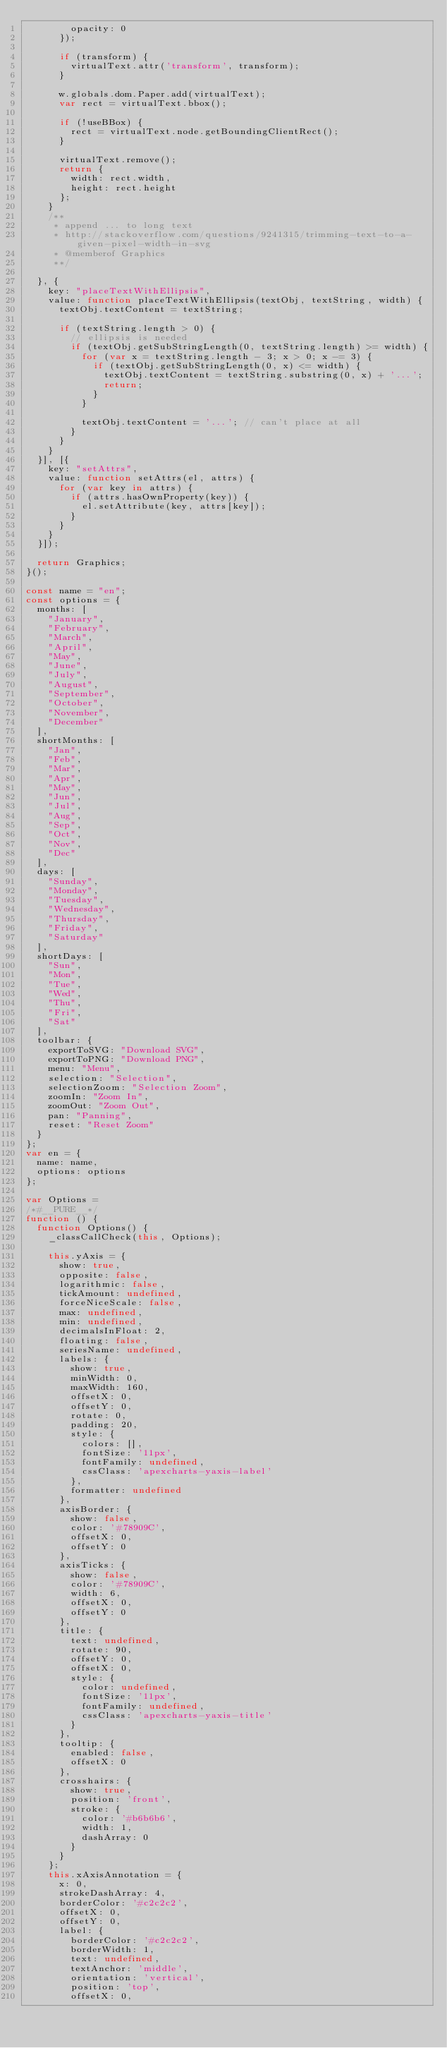Convert code to text. <code><loc_0><loc_0><loc_500><loc_500><_JavaScript_>        opacity: 0
      });

      if (transform) {
        virtualText.attr('transform', transform);
      }

      w.globals.dom.Paper.add(virtualText);
      var rect = virtualText.bbox();

      if (!useBBox) {
        rect = virtualText.node.getBoundingClientRect();
      }

      virtualText.remove();
      return {
        width: rect.width,
        height: rect.height
      };
    }
    /**
     * append ... to long text
     * http://stackoverflow.com/questions/9241315/trimming-text-to-a-given-pixel-width-in-svg
     * @memberof Graphics
     **/

  }, {
    key: "placeTextWithEllipsis",
    value: function placeTextWithEllipsis(textObj, textString, width) {
      textObj.textContent = textString;

      if (textString.length > 0) {
        // ellipsis is needed
        if (textObj.getSubStringLength(0, textString.length) >= width) {
          for (var x = textString.length - 3; x > 0; x -= 3) {
            if (textObj.getSubStringLength(0, x) <= width) {
              textObj.textContent = textString.substring(0, x) + '...';
              return;
            }
          }

          textObj.textContent = '...'; // can't place at all
        }
      }
    }
  }], [{
    key: "setAttrs",
    value: function setAttrs(el, attrs) {
      for (var key in attrs) {
        if (attrs.hasOwnProperty(key)) {
          el.setAttribute(key, attrs[key]);
        }
      }
    }
  }]);

  return Graphics;
}();

const name = "en";
const options = {
	months: [
		"January",
		"February",
		"March",
		"April",
		"May",
		"June",
		"July",
		"August",
		"September",
		"October",
		"November",
		"December"
	],
	shortMonths: [
		"Jan",
		"Feb",
		"Mar",
		"Apr",
		"May",
		"Jun",
		"Jul",
		"Aug",
		"Sep",
		"Oct",
		"Nov",
		"Dec"
	],
	days: [
		"Sunday",
		"Monday",
		"Tuesday",
		"Wednesday",
		"Thursday",
		"Friday",
		"Saturday"
	],
	shortDays: [
		"Sun",
		"Mon",
		"Tue",
		"Wed",
		"Thu",
		"Fri",
		"Sat"
	],
	toolbar: {
		exportToSVG: "Download SVG",
		exportToPNG: "Download PNG",
		menu: "Menu",
		selection: "Selection",
		selectionZoom: "Selection Zoom",
		zoomIn: "Zoom In",
		zoomOut: "Zoom Out",
		pan: "Panning",
		reset: "Reset Zoom"
	}
};
var en = {
	name: name,
	options: options
};

var Options =
/*#__PURE__*/
function () {
  function Options() {
    _classCallCheck(this, Options);

    this.yAxis = {
      show: true,
      opposite: false,
      logarithmic: false,
      tickAmount: undefined,
      forceNiceScale: false,
      max: undefined,
      min: undefined,
      decimalsInFloat: 2,
      floating: false,
      seriesName: undefined,
      labels: {
        show: true,
        minWidth: 0,
        maxWidth: 160,
        offsetX: 0,
        offsetY: 0,
        rotate: 0,
        padding: 20,
        style: {
          colors: [],
          fontSize: '11px',
          fontFamily: undefined,
          cssClass: 'apexcharts-yaxis-label'
        },
        formatter: undefined
      },
      axisBorder: {
        show: false,
        color: '#78909C',
        offsetX: 0,
        offsetY: 0
      },
      axisTicks: {
        show: false,
        color: '#78909C',
        width: 6,
        offsetX: 0,
        offsetY: 0
      },
      title: {
        text: undefined,
        rotate: 90,
        offsetY: 0,
        offsetX: 0,
        style: {
          color: undefined,
          fontSize: '11px',
          fontFamily: undefined,
          cssClass: 'apexcharts-yaxis-title'
        }
      },
      tooltip: {
        enabled: false,
        offsetX: 0
      },
      crosshairs: {
        show: true,
        position: 'front',
        stroke: {
          color: '#b6b6b6',
          width: 1,
          dashArray: 0
        }
      }
    };
    this.xAxisAnnotation = {
      x: 0,
      strokeDashArray: 4,
      borderColor: '#c2c2c2',
      offsetX: 0,
      offsetY: 0,
      label: {
        borderColor: '#c2c2c2',
        borderWidth: 1,
        text: undefined,
        textAnchor: 'middle',
        orientation: 'vertical',
        position: 'top',
        offsetX: 0,</code> 